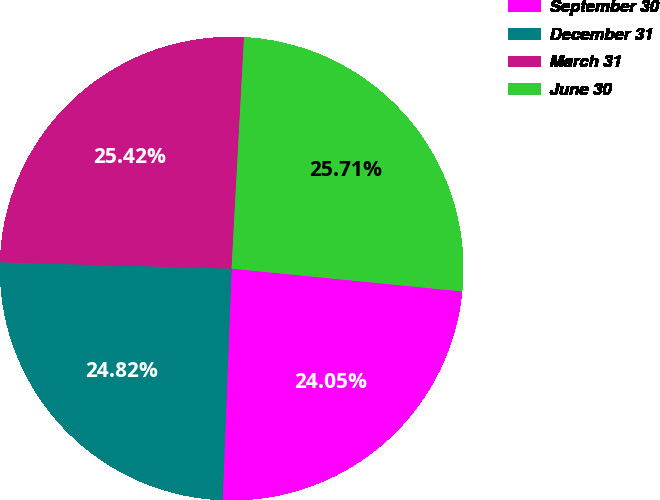Convert chart to OTSL. <chart><loc_0><loc_0><loc_500><loc_500><pie_chart><fcel>September 30<fcel>December 31<fcel>March 31<fcel>June 30<nl><fcel>24.05%<fcel>24.82%<fcel>25.42%<fcel>25.71%<nl></chart> 